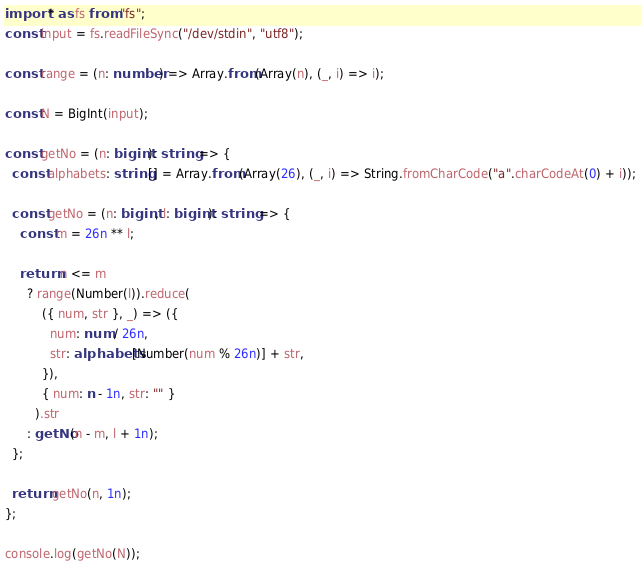Convert code to text. <code><loc_0><loc_0><loc_500><loc_500><_TypeScript_>import * as fs from "fs";
const input = fs.readFileSync("/dev/stdin", "utf8");

const range = (n: number) => Array.from(Array(n), (_, i) => i);

const N = BigInt(input);

const getNo = (n: bigint): string => {
  const alphabets: string[] = Array.from(Array(26), (_, i) => String.fromCharCode("a".charCodeAt(0) + i));

  const getNo = (n: bigint, l: bigint): string => {
    const m = 26n ** l;

    return n <= m
      ? range(Number(l)).reduce(
          ({ num, str }, _) => ({
            num: num / 26n,
            str: alphabets[Number(num % 26n)] + str,
          }),
          { num: n - 1n, str: "" }
        ).str
      : getNo(n - m, l + 1n);
  };

  return getNo(n, 1n);
};

console.log(getNo(N));
</code> 